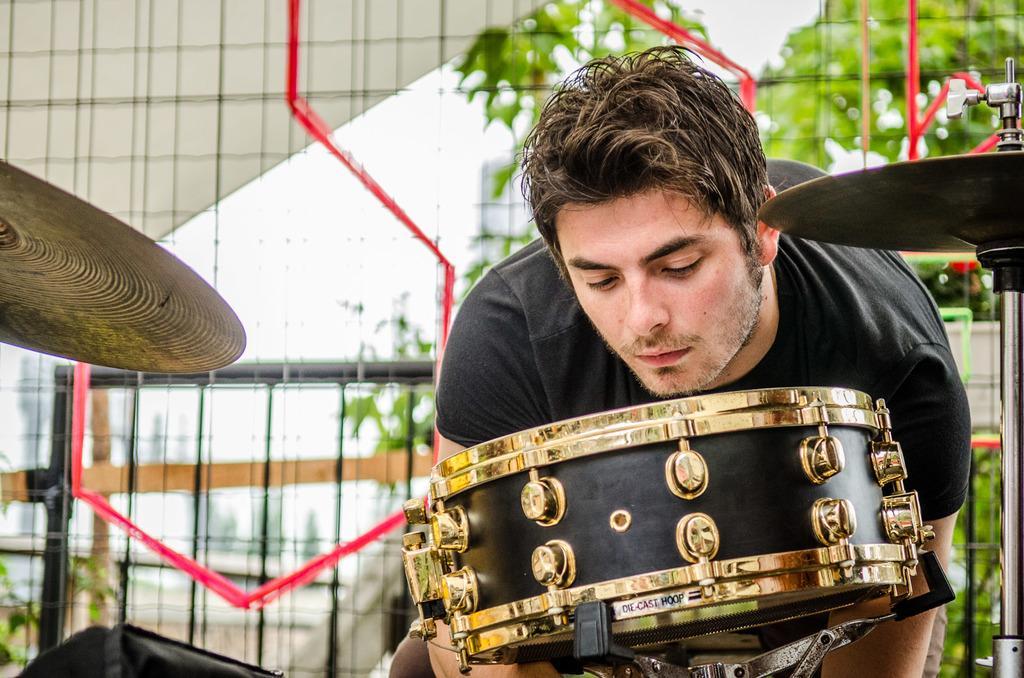Could you give a brief overview of what you see in this image? In this image, we can see a person bending and in the background, we can see musical instruments and there are trees and we can see a mesh. 